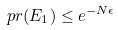Convert formula to latex. <formula><loc_0><loc_0><loc_500><loc_500>\ p r ( E _ { 1 } ) \leq e ^ { - N \epsilon }</formula> 